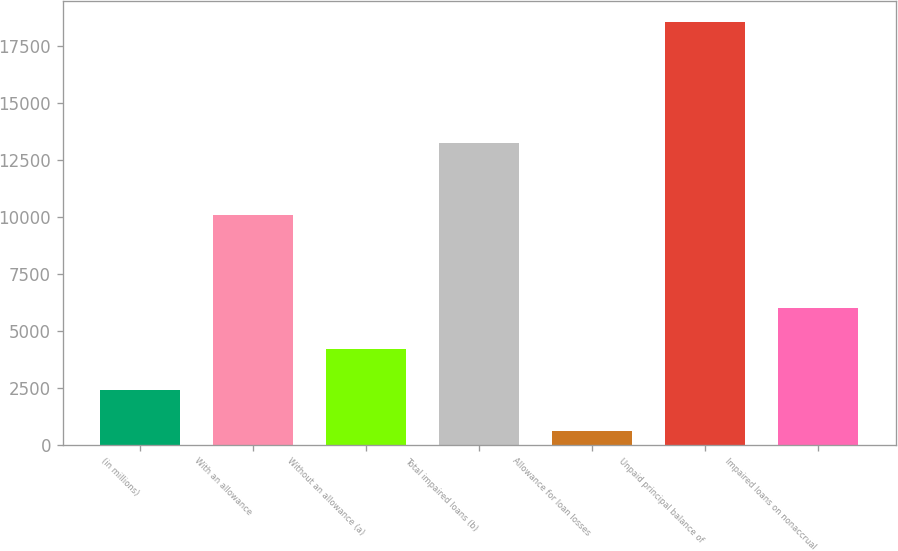Convert chart to OTSL. <chart><loc_0><loc_0><loc_500><loc_500><bar_chart><fcel>(in millions)<fcel>With an allowance<fcel>Without an allowance (a)<fcel>Total impaired loans (b)<fcel>Allowance for loan losses<fcel>Unpaid principal balance of<fcel>Impaired loans on nonaccrual<nl><fcel>2387.4<fcel>10100<fcel>4183.8<fcel>13245<fcel>591<fcel>18555<fcel>5980.2<nl></chart> 